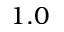<formula> <loc_0><loc_0><loc_500><loc_500>1 . 0</formula> 